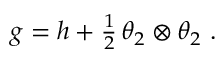Convert formula to latex. <formula><loc_0><loc_0><loc_500><loc_500>\begin{array} { r } { g = h + \frac { 1 } { 2 } \, \theta _ { 2 } \otimes \theta _ { 2 } \ . } \end{array}</formula> 